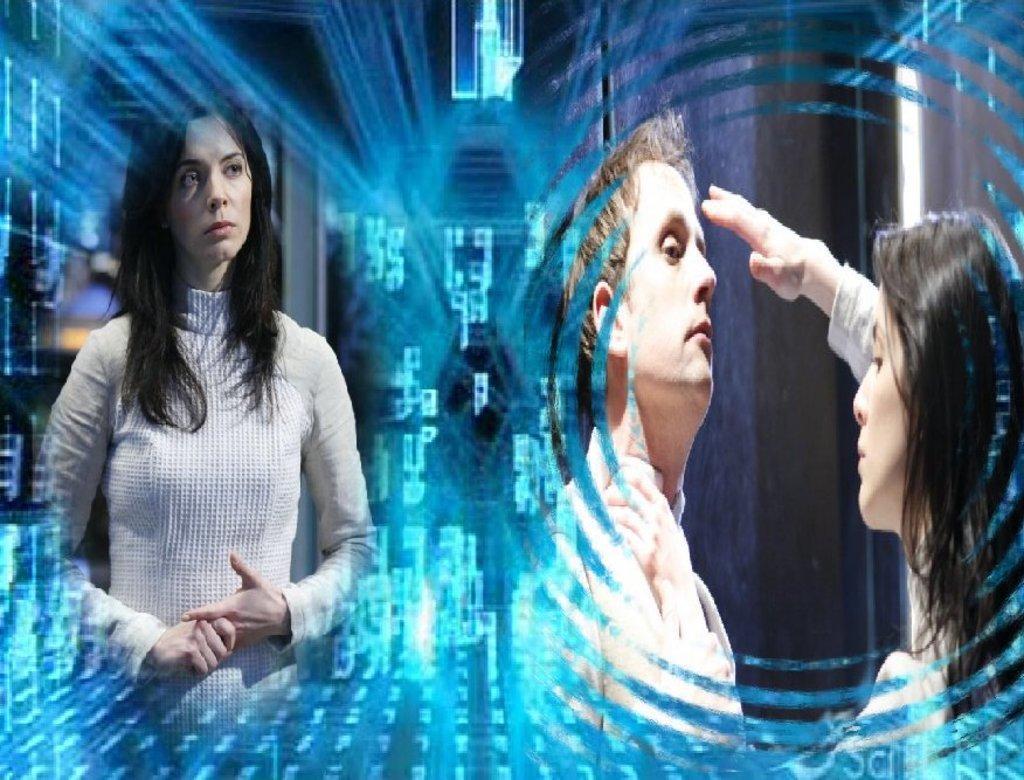Please provide a concise description of this image. This is an edited picture, we can see there are three people on the path and behind there are some other things. 